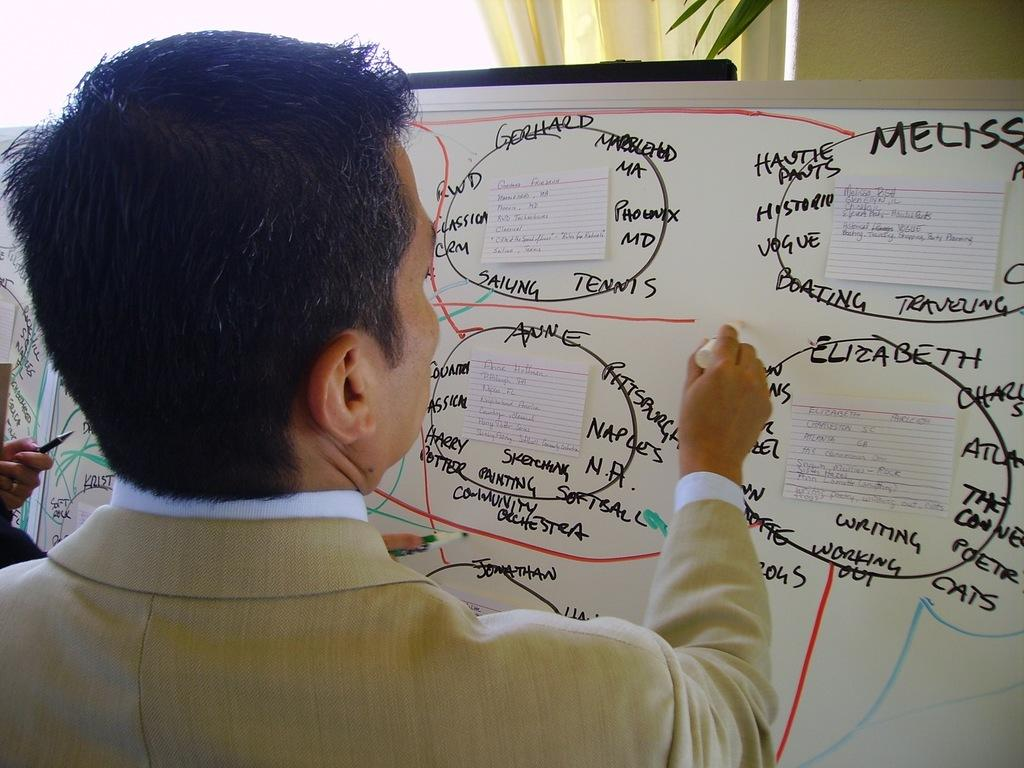<image>
Describe the image concisely. Several names, including "Elizabeth" are written on a white board. 